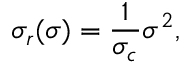<formula> <loc_0><loc_0><loc_500><loc_500>\sigma _ { r } ( \sigma ) = \frac { 1 } { \sigma _ { c } } \sigma ^ { 2 } ,</formula> 